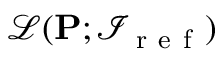Convert formula to latex. <formula><loc_0><loc_0><loc_500><loc_500>\ m a t h s c r { L } ( P ; \mathcal { I } _ { r e f } )</formula> 